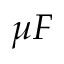<formula> <loc_0><loc_0><loc_500><loc_500>\mu F</formula> 